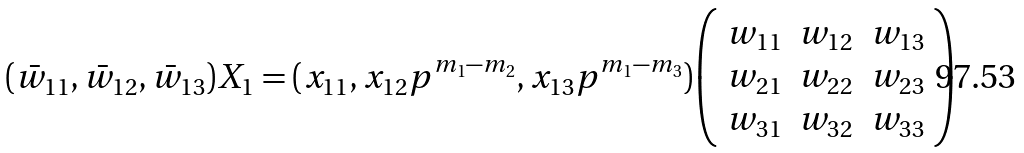<formula> <loc_0><loc_0><loc_500><loc_500>( \bar { w } _ { 1 1 } , \bar { w } _ { 1 2 } , \bar { w } _ { 1 3 } ) X _ { 1 } = ( x _ { 1 1 } , x _ { 1 2 } p ^ { m _ { 1 } - m _ { 2 } } , x _ { 1 3 } p ^ { m _ { 1 } - m _ { 3 } } ) { \left ( \begin{array} { c c c } w _ { 1 1 } & w _ { 1 2 } & w _ { 1 3 } \\ w _ { 2 1 } & w _ { 2 2 } & w _ { 2 3 } \\ w _ { 3 1 } & w _ { 3 2 } & w _ { 3 3 } \end{array} \right ) }</formula> 